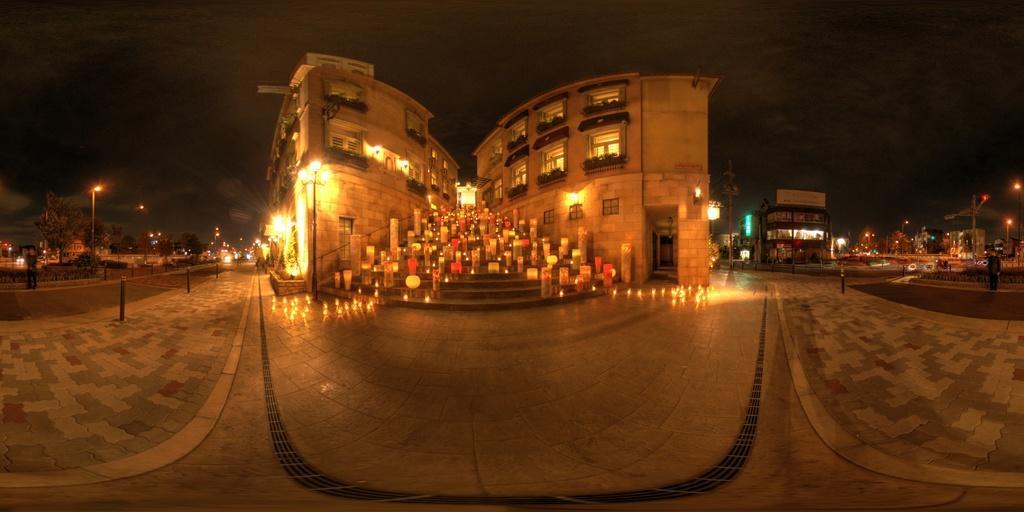How would you summarize this image in a sentence or two? In the middle I can see a building, staircase, group of people and poles. In the left I can see a fence, light poles, trees and a person is standing. On the right I can see a vehicle and plants. In the background I can see the sky. This image is taken during night on the road. 